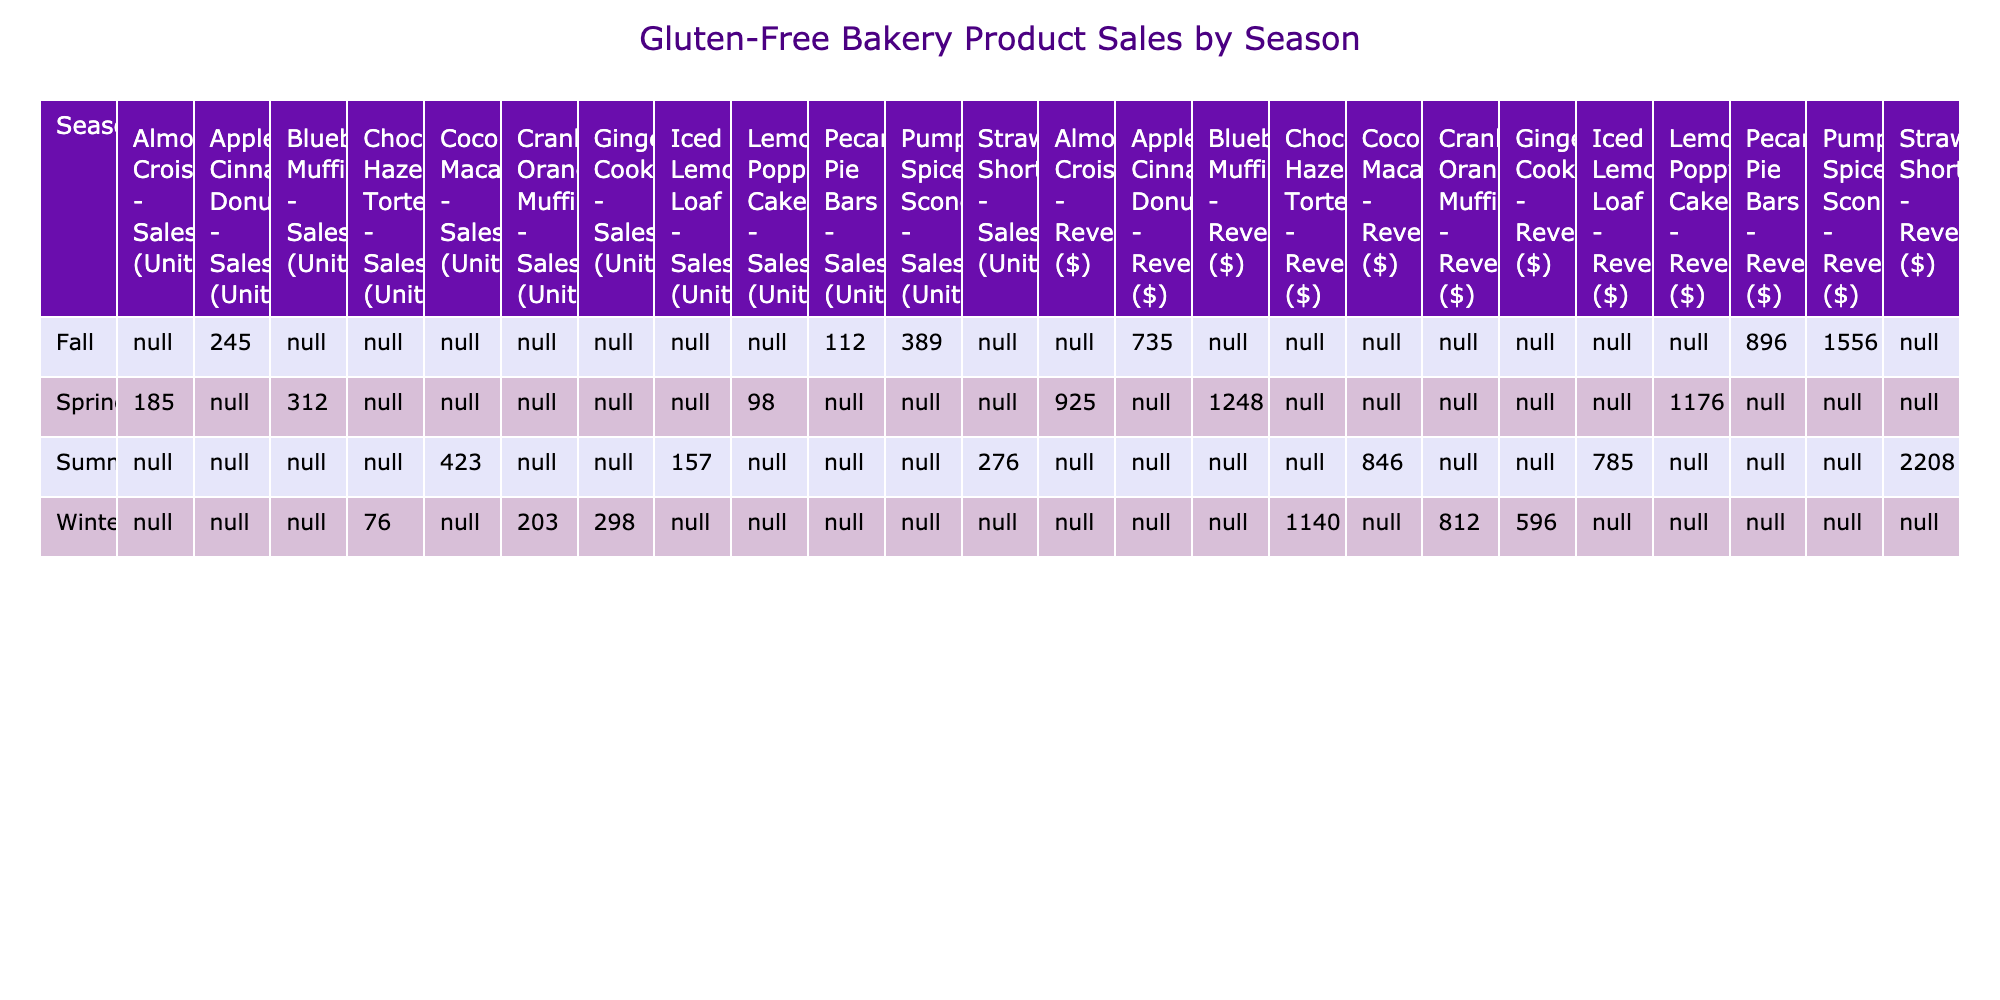What is the total sales in units of Almond Croissants during Spring? The table lists the sales of Almond Croissants during Spring as 185 units. Since there is only one season listed, no further calculation is needed.
Answer: 185 During which season were the Coconut Macaroons sold the most, and how many units were sold? The table shows Coconut Macaroons were sold during Summer with total sales of 423 units. This is the highest sales figure for this product across all seasons listed.
Answer: Summer, 423 What is the total revenue generated from Pumpkin Spice Scones and Apple Cinnamon Donuts in Fall? The table shows that Pumpkin Spice Scones generated a revenue of $1556 and Apple Cinnamon Donuts generated $735. Adding these two revenues gives $1556 + $735 = $2291.
Answer: $2291 Which seasonal product has the highest sales in units, and what is that amount? By examining the sales figures across all seasons, Coconut Macaroons have the highest sales with 423 units sold during Summer.
Answer: Coconut Macaroons, 423 Is it true that the Gingerbread Cookies generated more revenue than the Chocolate Hazelnut Torte during Winter? The table shows Gingerbread Cookies generated $596, while Chocolate Hazelnut Torte generated $1140. Since $596 is less than $1140, this statement is false.
Answer: False What is the average revenue of gluten-free products sold during Winter? The table lists three products sold during Winter with revenues of $596, $1140, and $812. The average is calculated as (596 + 1140 + 812) / 3 = 849.33, rounded it gives approximately $849.
Answer: $849 If we combine the sales of all products in Fall, what are the total sales in units? The table shows the sales for Fall products: Pumpkin Spice Scones (389), Apple Cinnamon Donuts (245), and Pecan Pie Bars (112). Adding these gives total sales as 389 + 245 + 112 = 746 units.
Answer: 746 In total, how much revenue was generated from all the gluten-free products in Spring? The revenue for Spring products listed are: Blueberry Muffins ($1248), Almond Croissants ($925), and Lemon Poppyseed Cake ($1176). Adding these gives $1248 + $925 + $1176 = $3349.
Answer: $3349 Which product had the lowest sales in Winter, and how many units were sold? The table shows the sales in Winter: Gingerbread Cookies (298), Chocolate Hazelnut Torte (76), and Cranberry Orange Muffins (203). The product with the lowest sales is the Chocolate Hazelnut Torte with 76 units.
Answer: Chocolate Hazelnut Torte, 76 What is the sum of sales units across all products in Summer? The table indicates sales in Summer for Strawberry Shortcake (276), Coconut Macaroons (423), and Iced Lemon Loaf (157). Summing these gives: 276 + 423 + 157 = 856 units sold in Summer.
Answer: 856 